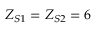Convert formula to latex. <formula><loc_0><loc_0><loc_500><loc_500>Z _ { S 1 } = Z _ { S 2 } = 6</formula> 